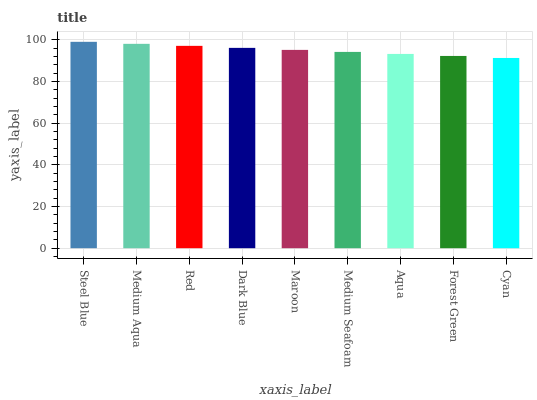Is Cyan the minimum?
Answer yes or no. Yes. Is Steel Blue the maximum?
Answer yes or no. Yes. Is Medium Aqua the minimum?
Answer yes or no. No. Is Medium Aqua the maximum?
Answer yes or no. No. Is Steel Blue greater than Medium Aqua?
Answer yes or no. Yes. Is Medium Aqua less than Steel Blue?
Answer yes or no. Yes. Is Medium Aqua greater than Steel Blue?
Answer yes or no. No. Is Steel Blue less than Medium Aqua?
Answer yes or no. No. Is Maroon the high median?
Answer yes or no. Yes. Is Maroon the low median?
Answer yes or no. Yes. Is Dark Blue the high median?
Answer yes or no. No. Is Aqua the low median?
Answer yes or no. No. 